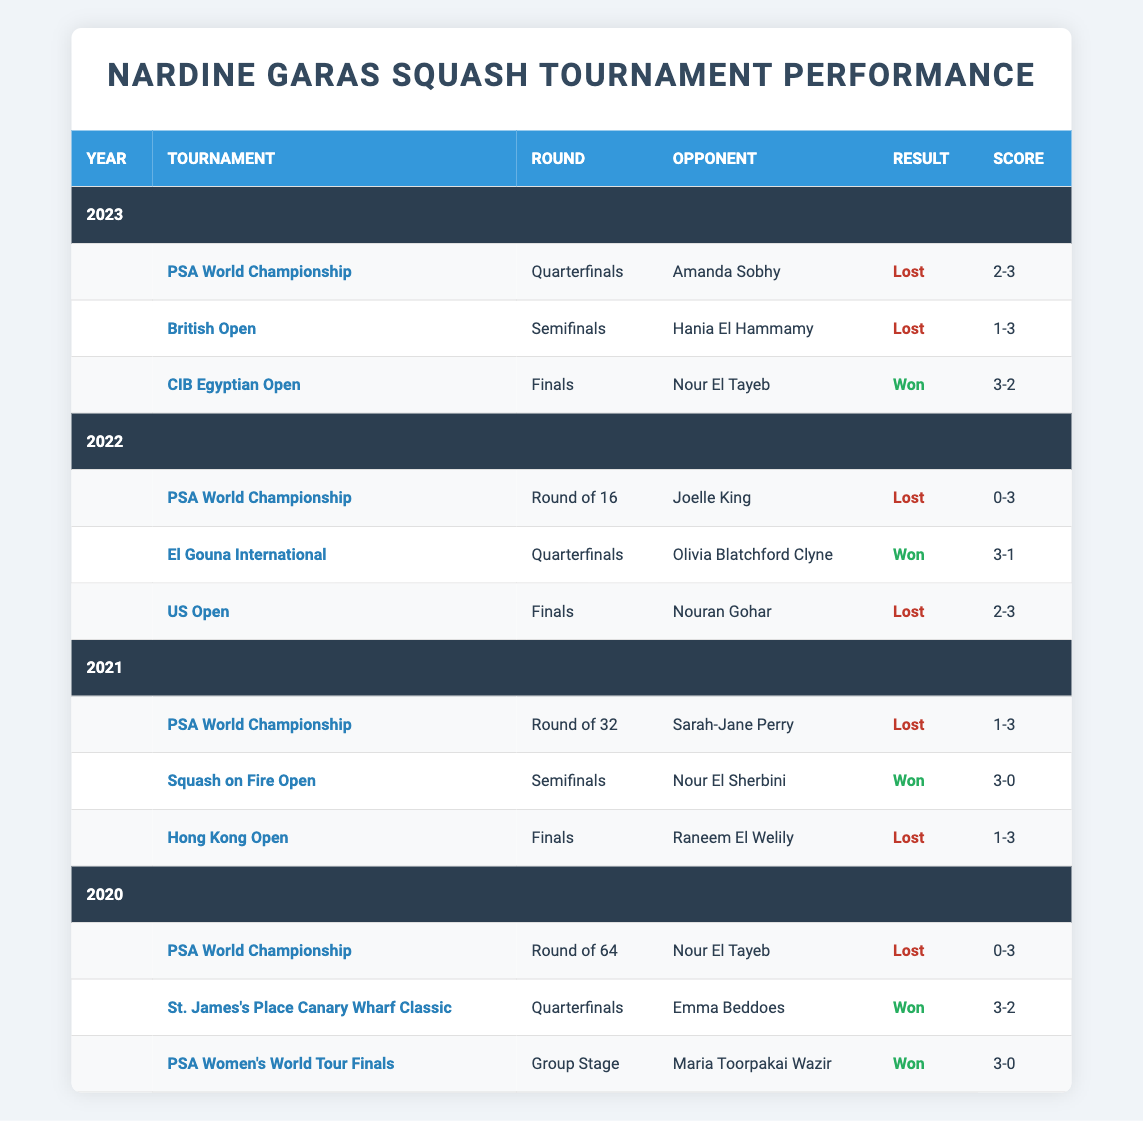What was Nardine Garas' performance in the CIB Egyptian Open in 2023? Nardine Garas reached the Finals of the CIB Egyptian Open in 2023, where she played against Nour El Tayeb. She won the match with a score of 3-2.
Answer: Won How many tournaments did Nardine Garas compete in during 2021? Nardine Garas competed in three tournaments in 2021: PSA World Championship, Squash on Fire Open, and Hong Kong Open.
Answer: 3 Did Nardine Garas win any matches in the PSA World Championship across the provided years? No, Nardine Garas lost all her matches in the PSA World Championship in 2020, 2021, and 2022.
Answer: No What was the score of Nardine Garas' match against Nour El Tayeb in 2020? Nardine Garas played against Nour El Tayeb in the Round of 64 at the PSA World Championship in 2020 and lost the match with a score of 0-3.
Answer: 0-3 How many finals did Nardine Garas reach from 2020 to 2023? Nardine Garas reached the finals in 2022 (US Open) and 2023 (CIB Egyptian Open), totaling two finals in this period.
Answer: 2 Which opponent did Nardine Garas lose to in the 2023 British Open, and what was the score? Nardine Garas lost to Hania El Hammamy in the semifinals of the 2023 British Open, with a score of 1-3.
Answer: Hania El Hammamy, 1-3 In 2022, how did Nardine Garas perform against Joelle King in the PSA World Championship? Nardine Garas played against Joelle King in the Round of 16 of the PSA World Championship in 2022 and lost the match with a score of 0-3.
Answer: Lost, 0-3 How many matches did Nardine Garas win in the 2020 season? In 2020, Nardine Garas won two matches: against Emma Beddoes at the St. James's Place Canary Wharf Classic and Maria Toorpakai Wazir at the PSA Women's World Tour Finals.
Answer: 2 What was the outcome of the Squash on Fire Open in 2021 for Nardine Garas? Nardine Garas reached the semifinals of the Squash on Fire Open in 2021 and won the match against Nour El Sherbini with a score of 3-0.
Answer: Won In which year did Nardine Garas achieve her only victory over Nour El Tayeb? Nardine Garas achieved her only victory over Nour El Tayeb in 2023 during the CIB Egyptian Open finals.
Answer: 2023 